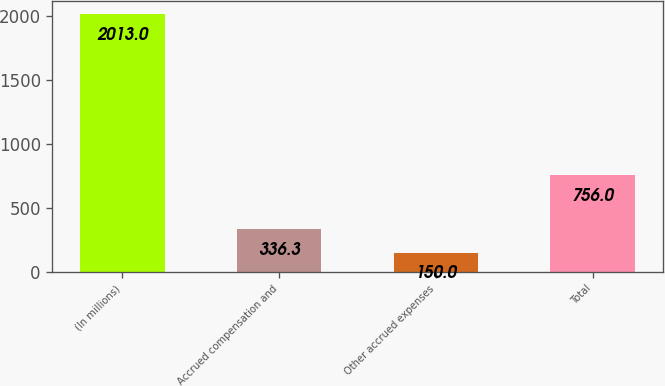<chart> <loc_0><loc_0><loc_500><loc_500><bar_chart><fcel>(In millions)<fcel>Accrued compensation and<fcel>Other accrued expenses<fcel>Total<nl><fcel>2013<fcel>336.3<fcel>150<fcel>756<nl></chart> 